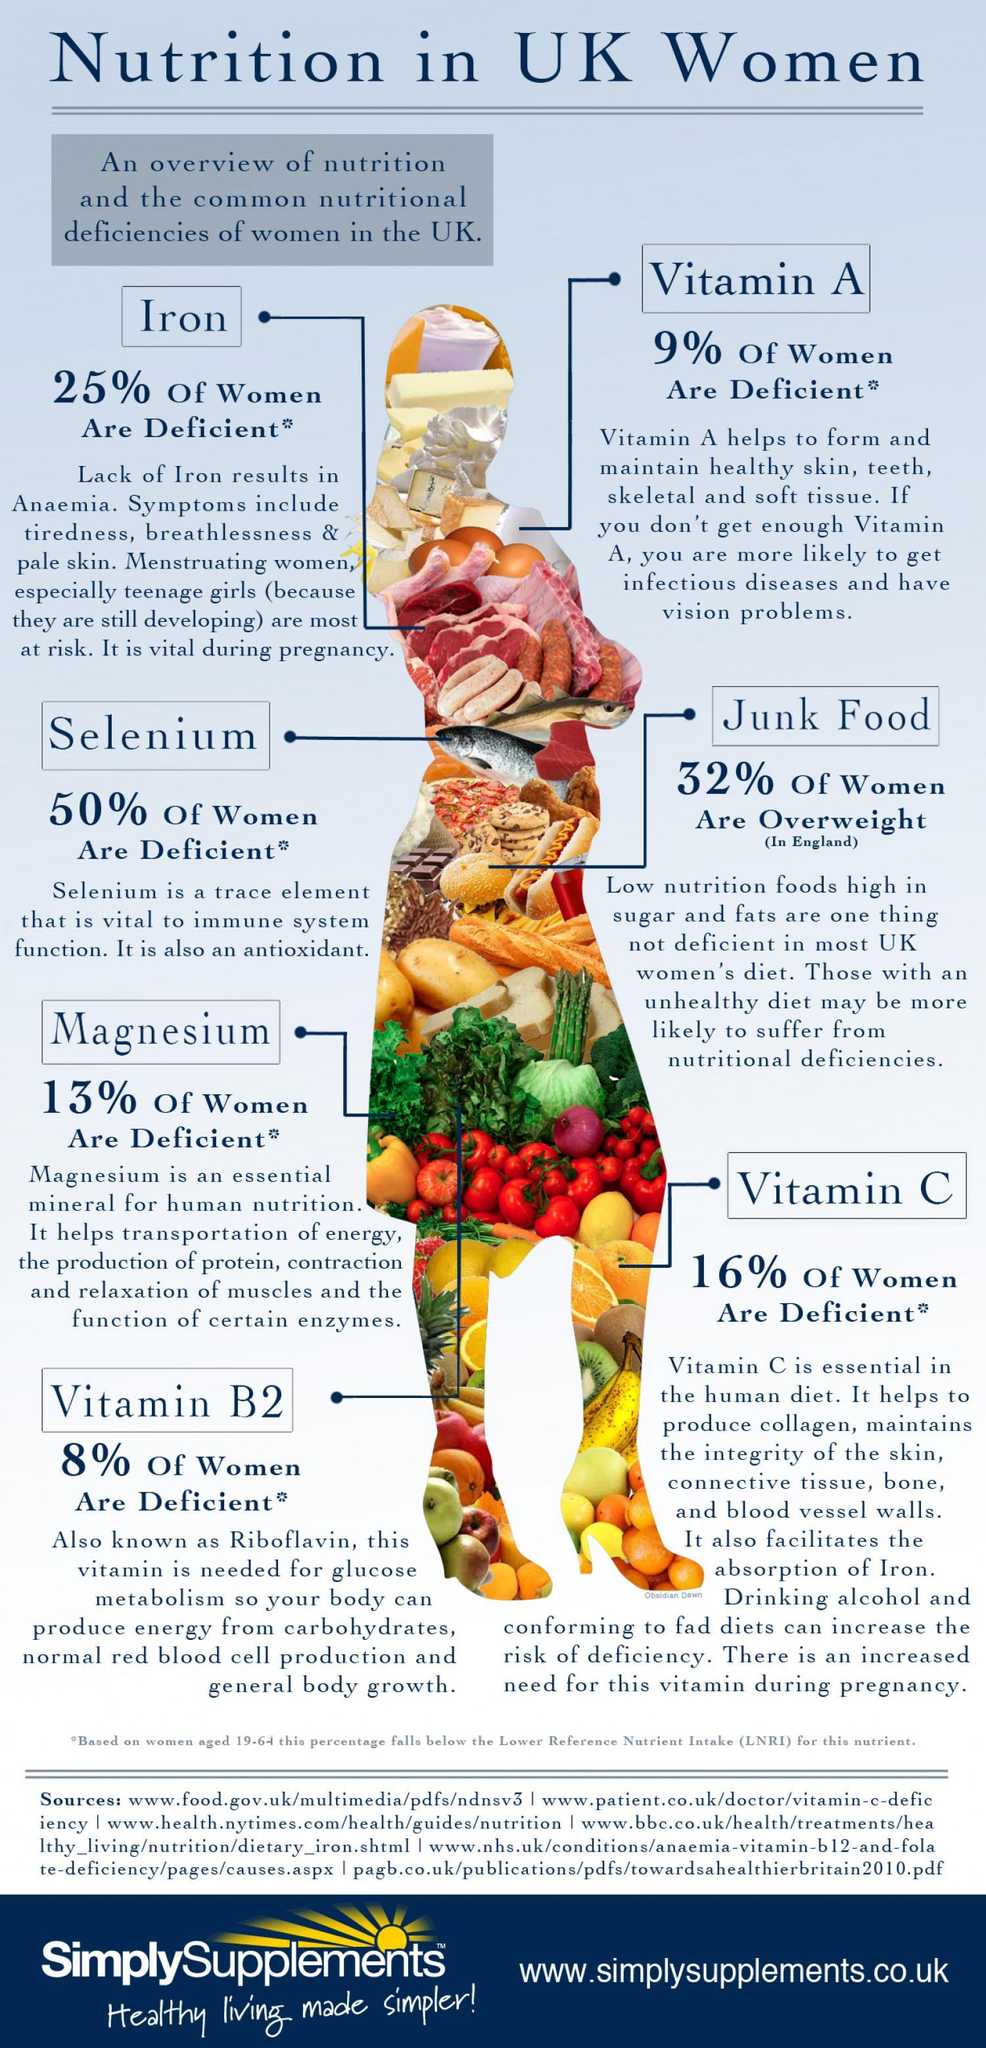What percentage of women in U.K. are deficient in Selenium?
Answer the question with a short phrase. 50% What percentage of women in U.K. are deficient in Vitamin C? 16% What is the other name for Vitamin B2? Riboflavin What percentage of women in England are not overweight? 68% What percentage of women in U.K. are not deficient in Iron? 75% What percentage of women in U.K. are not deficient in Vitamin A? 91% 